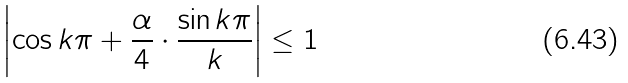Convert formula to latex. <formula><loc_0><loc_0><loc_500><loc_500>\left | \cos k \pi + \frac { \alpha } { 4 } \cdot \frac { \sin k \pi } { k } \right | \leq 1</formula> 